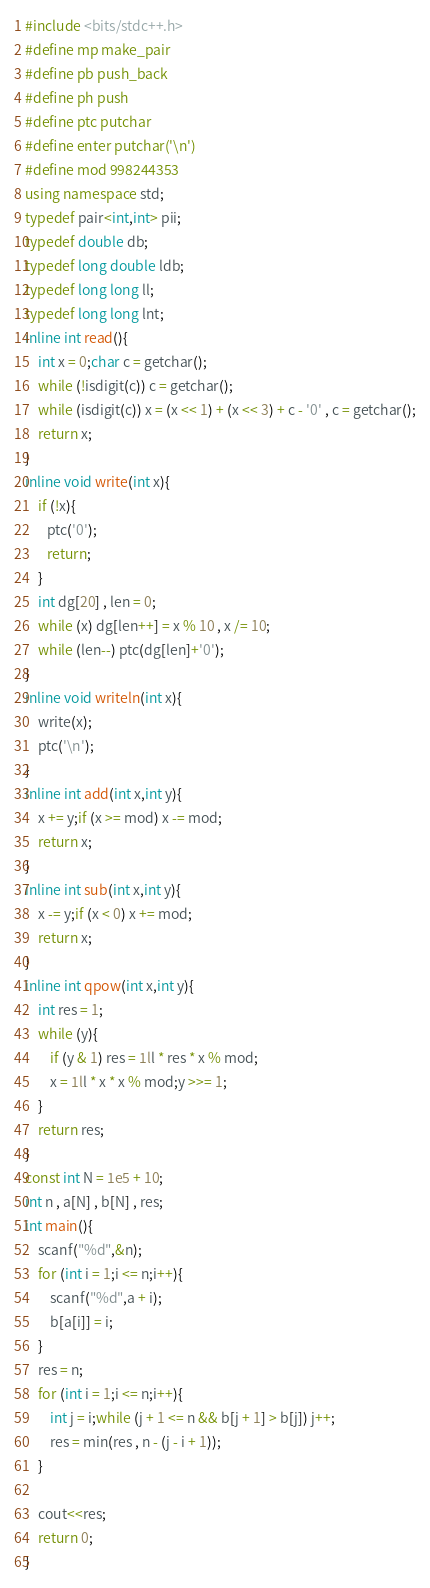Convert code to text. <code><loc_0><loc_0><loc_500><loc_500><_C++_>#include <bits/stdc++.h>
#define mp make_pair
#define pb push_back
#define ph push
#define ptc putchar
#define enter putchar('\n')
#define mod 998244353
using namespace std;
typedef pair<int,int> pii;
typedef double db;
typedef long double ldb;
typedef long long ll;
typedef long long lnt;
inline int read(){
	int x = 0;char c = getchar();
	while (!isdigit(c)) c = getchar();
	while (isdigit(c)) x = (x << 1) + (x << 3) + c - '0' , c = getchar();
	return x;
}
inline void write(int x){
	if (!x){
       ptc('0');
       return;
	}
	int dg[20] , len = 0;
	while (x) dg[len++] = x % 10 , x /= 10;
	while (len--) ptc(dg[len]+'0');
}
inline void writeln(int x){
	write(x);
	ptc('\n');
}
inline int add(int x,int y){
	x += y;if (x >= mod) x -= mod;
	return x;
}
inline int sub(int x,int y){
	x -= y;if (x < 0) x += mod;
	return x;
}
inline int qpow(int x,int y){
	int res = 1;
	while (y){
		if (y & 1) res = 1ll * res * x % mod;
		x = 1ll * x * x % mod;y >>= 1;
	}
	return res;
}
const int N = 1e5 + 10;
int n , a[N] , b[N] , res;
int main(){
	scanf("%d",&n);
	for (int i = 1;i <= n;i++){
		scanf("%d",a + i);
		b[a[i]] = i;
	}	
	res = n;
	for (int i = 1;i <= n;i++){
		int j = i;while (j + 1 <= n && b[j + 1] > b[j]) j++;
		res = min(res , n - (j - i + 1));
	}
	
	cout<<res;
	return 0;
}
</code> 